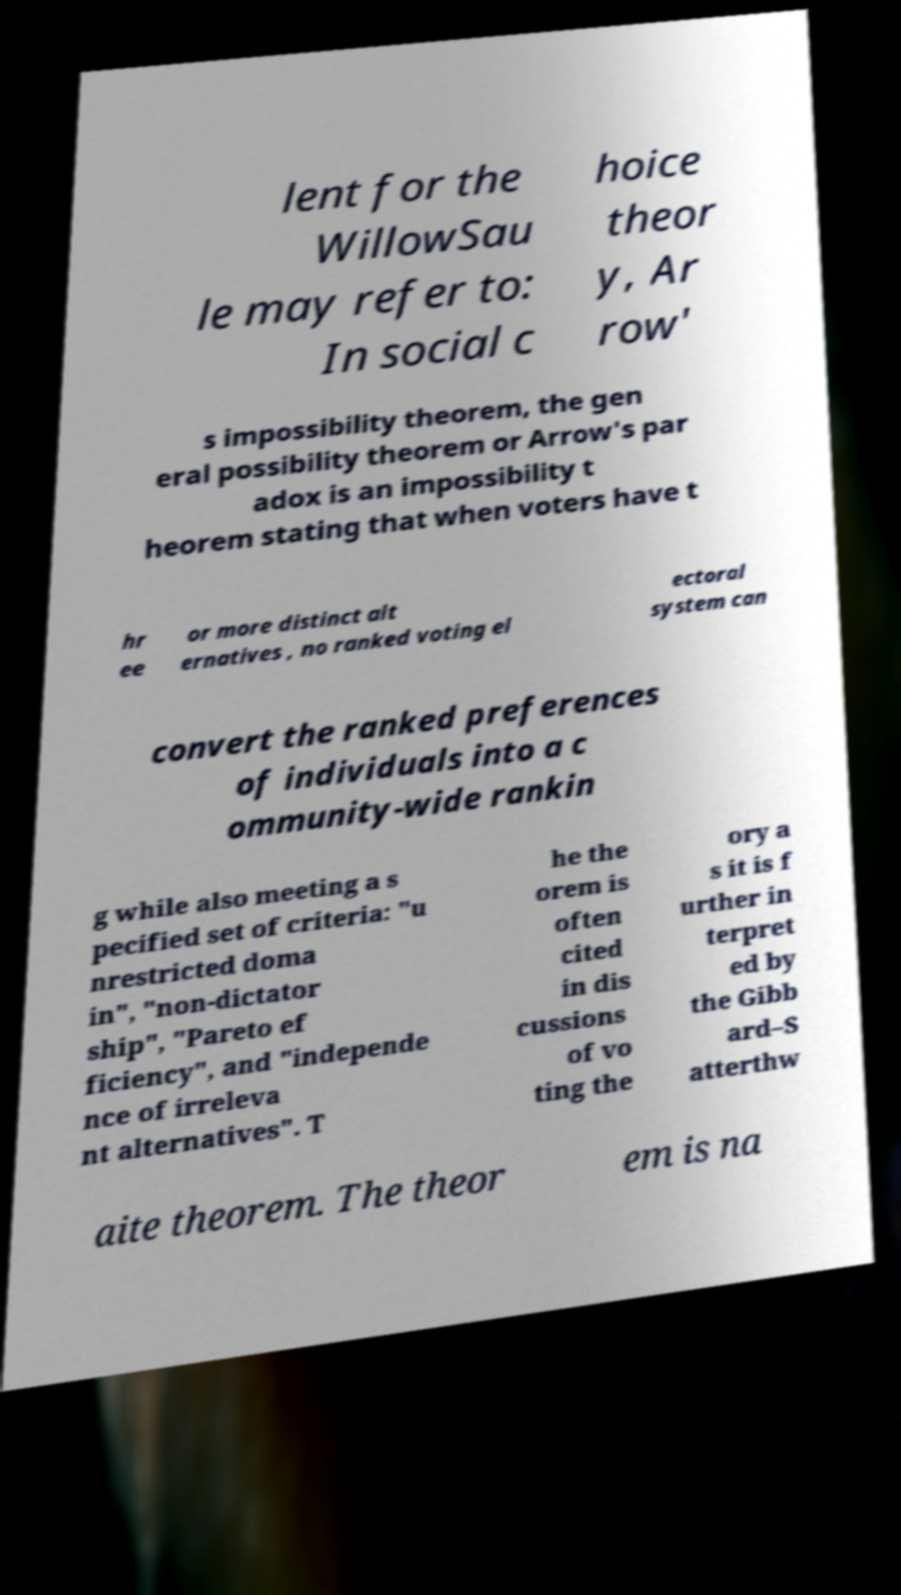Can you read and provide the text displayed in the image?This photo seems to have some interesting text. Can you extract and type it out for me? lent for the WillowSau le may refer to: In social c hoice theor y, Ar row' s impossibility theorem, the gen eral possibility theorem or Arrow's par adox is an impossibility t heorem stating that when voters have t hr ee or more distinct alt ernatives , no ranked voting el ectoral system can convert the ranked preferences of individuals into a c ommunity-wide rankin g while also meeting a s pecified set of criteria: "u nrestricted doma in", "non-dictator ship", "Pareto ef ficiency", and "independe nce of irreleva nt alternatives". T he the orem is often cited in dis cussions of vo ting the ory a s it is f urther in terpret ed by the Gibb ard–S atterthw aite theorem. The theor em is na 